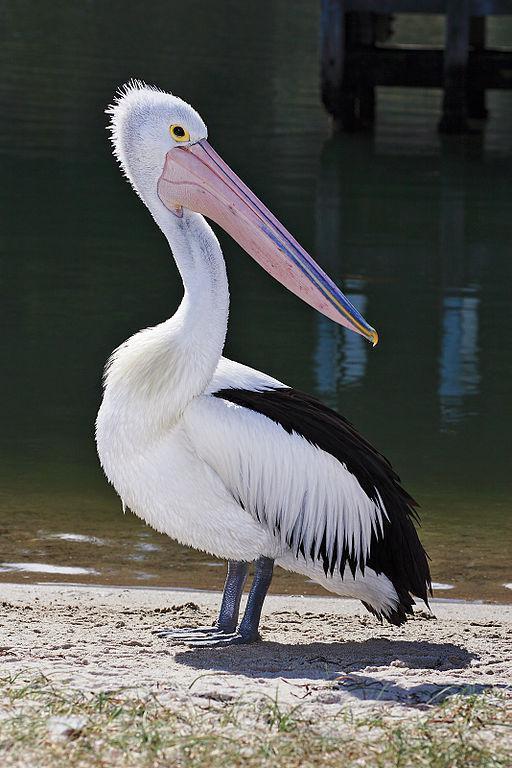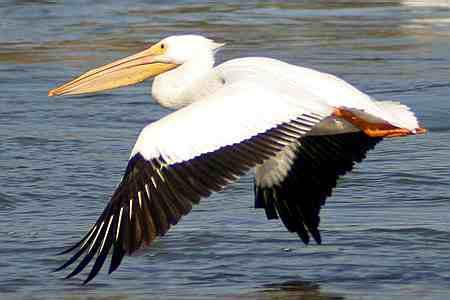The first image is the image on the left, the second image is the image on the right. Considering the images on both sides, is "The bird in the left image has a fish in it's beak." valid? Answer yes or no. No. The first image is the image on the left, the second image is the image on the right. Given the left and right images, does the statement "There a single bird with black and white feathers facing left." hold true? Answer yes or no. Yes. 